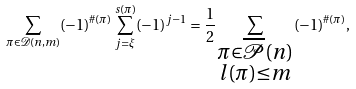Convert formula to latex. <formula><loc_0><loc_0><loc_500><loc_500>\sum _ { \pi \in \mathcal { D } ( n , m ) } ( - 1 ) ^ { \# ( \pi ) } \sum _ { j = \xi } ^ { s ( \pi ) } ( - 1 ) ^ { j - 1 } = \frac { 1 } { 2 } \sum _ { \substack { \pi \in \overline { \mathcal { P } } ( n ) \\ l ( \pi ) \leq m } } ( - 1 ) ^ { \# ( \pi ) } ,</formula> 